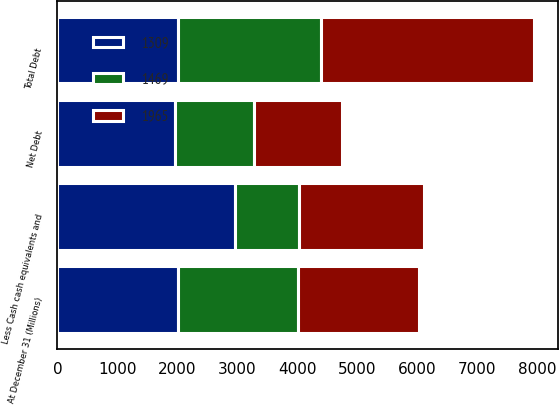Convert chart to OTSL. <chart><loc_0><loc_0><loc_500><loc_500><stacked_bar_chart><ecel><fcel>At December 31 (Millions)<fcel>Total Debt<fcel>Less Cash cash equivalents and<fcel>Net Debt<nl><fcel>1309<fcel>2007<fcel>2006<fcel>2955<fcel>1965<nl><fcel>1965<fcel>2006<fcel>3553<fcel>2084<fcel>1469<nl><fcel>1469<fcel>2005<fcel>2381<fcel>1072<fcel>1309<nl></chart> 